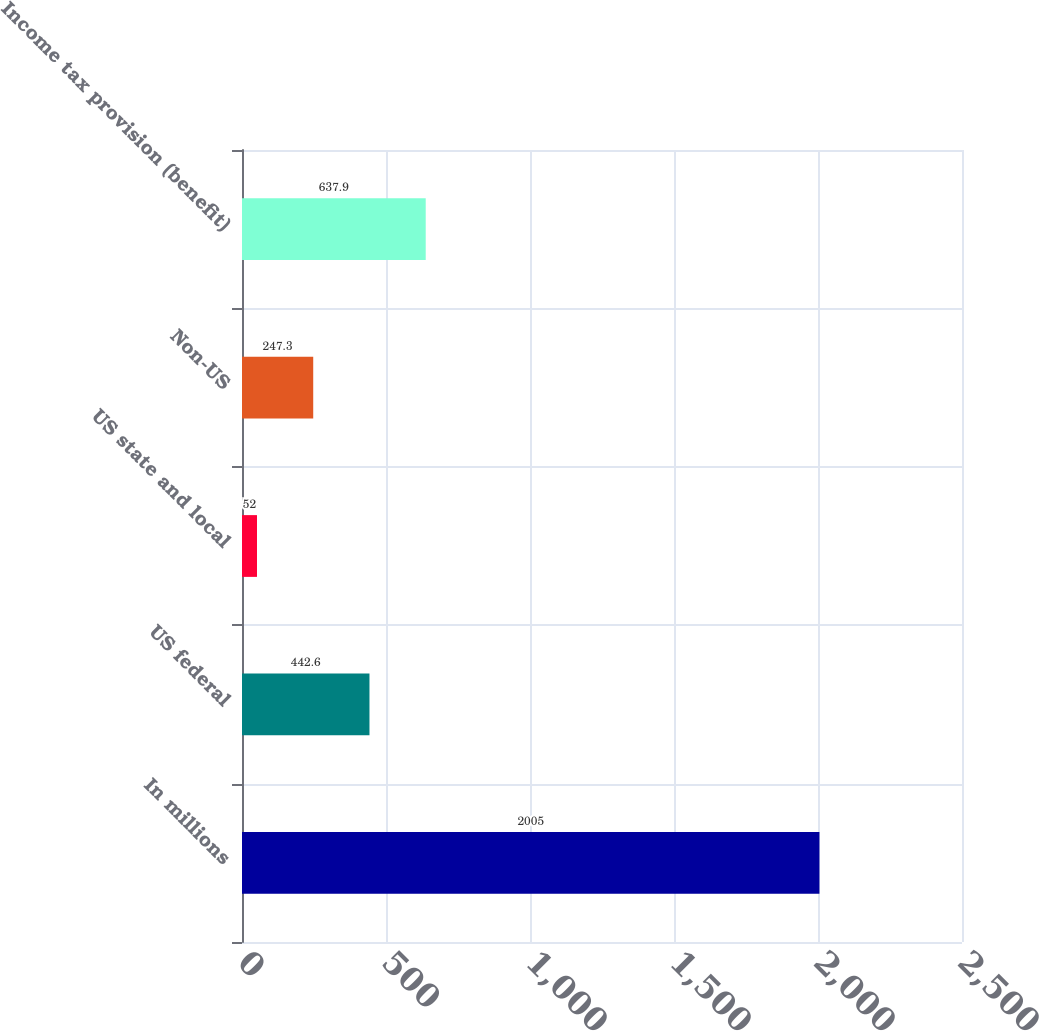<chart> <loc_0><loc_0><loc_500><loc_500><bar_chart><fcel>In millions<fcel>US federal<fcel>US state and local<fcel>Non-US<fcel>Income tax provision (benefit)<nl><fcel>2005<fcel>442.6<fcel>52<fcel>247.3<fcel>637.9<nl></chart> 